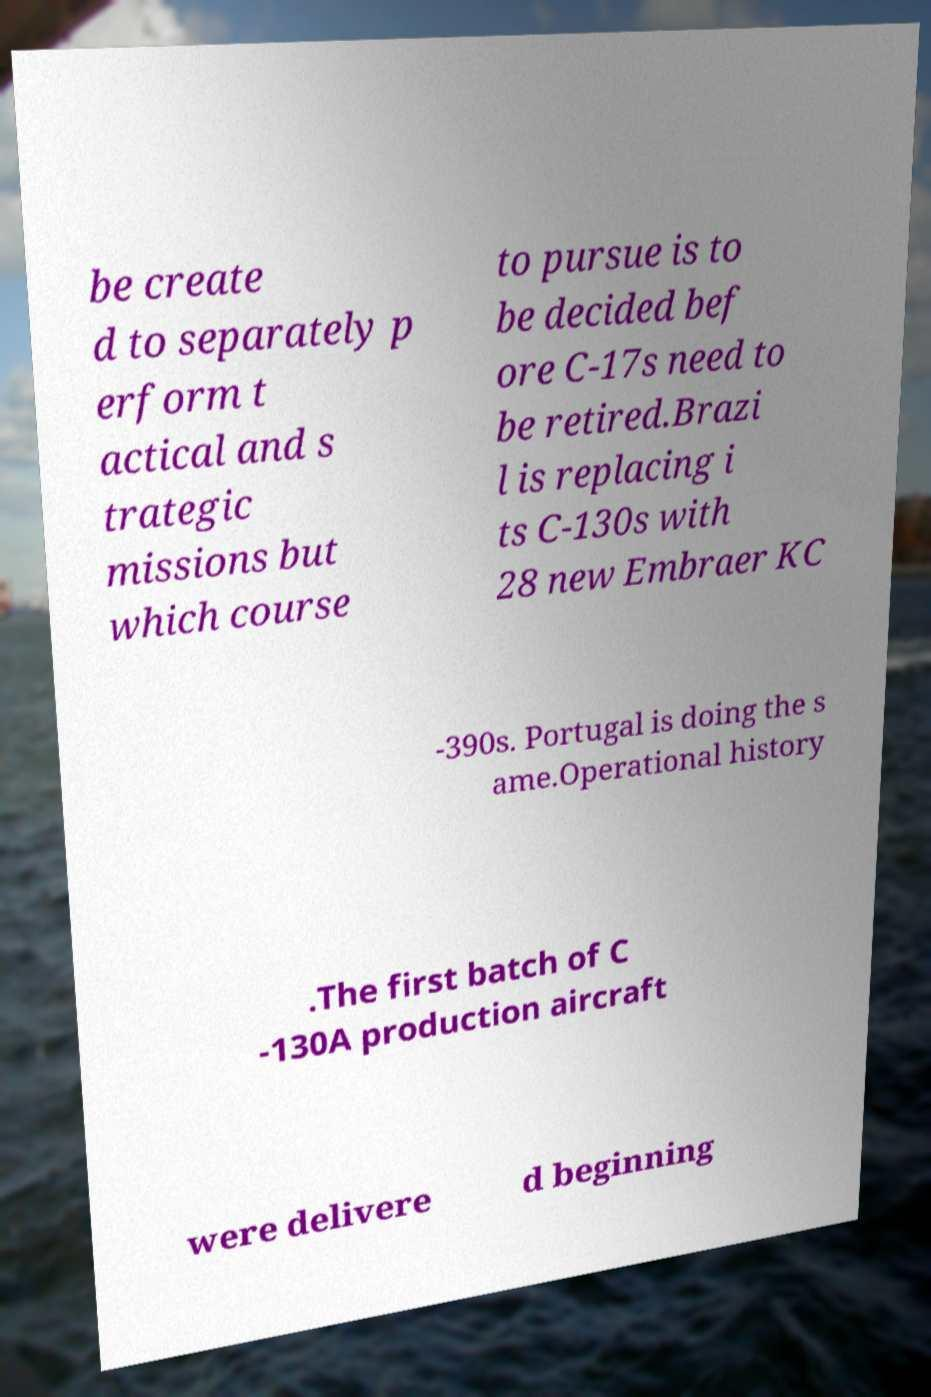For documentation purposes, I need the text within this image transcribed. Could you provide that? be create d to separately p erform t actical and s trategic missions but which course to pursue is to be decided bef ore C-17s need to be retired.Brazi l is replacing i ts C-130s with 28 new Embraer KC -390s. Portugal is doing the s ame.Operational history .The first batch of C -130A production aircraft were delivere d beginning 